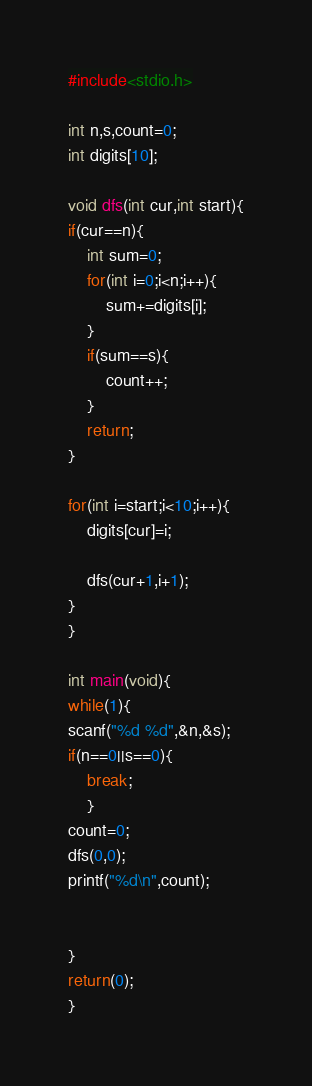<code> <loc_0><loc_0><loc_500><loc_500><_C_>#include<stdio.h>

int n,s,count=0;
int digits[10];

void dfs(int cur,int start){
if(cur==n){
	int sum=0;
	for(int i=0;i<n;i++){
		sum+=digits[i];
	}
	if(sum==s){
		count++;
	}
	return;
}

for(int i=start;i<10;i++){
	digits[cur]=i;
    
	dfs(cur+1,i+1);
}
}

int main(void){
while(1){
scanf("%d %d",&n,&s);
if(n==0||s==0){ 
    break;
    }
count=0;
dfs(0,0);
printf("%d\n",count);

    
}
return(0);
}
</code> 